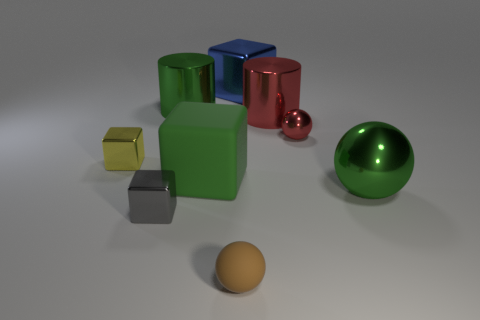What number of objects are either metallic cylinders or small gray cubes?
Your answer should be compact. 3. What material is the big ball that is the same color as the large rubber thing?
Offer a very short reply. Metal. Is there another gray metallic thing of the same shape as the small gray object?
Provide a short and direct response. No. How many things are in front of the green metallic ball?
Keep it short and to the point. 2. What is the ball that is to the right of the tiny ball that is behind the yellow metal thing made of?
Give a very brief answer. Metal. There is a yellow cube that is the same size as the gray metallic thing; what is it made of?
Offer a very short reply. Metal. Are there any red metallic objects of the same size as the brown ball?
Your answer should be compact. Yes. There is a large cylinder to the left of the red cylinder; what is its color?
Your answer should be very brief. Green. There is a large sphere that is on the right side of the rubber ball; are there any large green things that are to the left of it?
Provide a short and direct response. Yes. What number of other things are the same color as the big rubber block?
Keep it short and to the point. 2. 